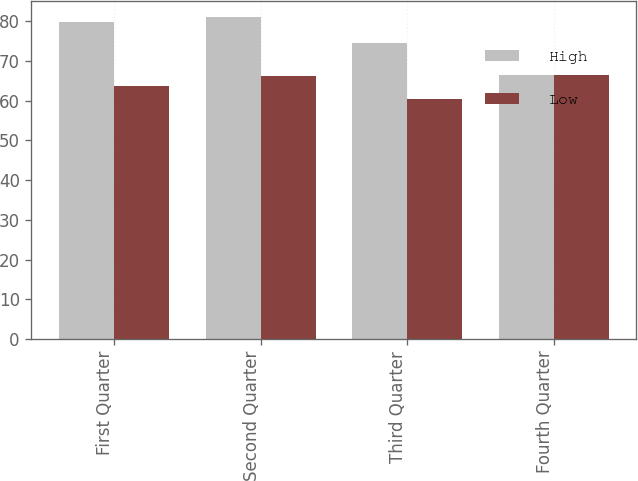Convert chart to OTSL. <chart><loc_0><loc_0><loc_500><loc_500><stacked_bar_chart><ecel><fcel>First Quarter<fcel>Second Quarter<fcel>Third Quarter<fcel>Fourth Quarter<nl><fcel>High<fcel>79.78<fcel>80.92<fcel>74.55<fcel>66.42<nl><fcel>Low<fcel>63.8<fcel>66.12<fcel>60.41<fcel>66.42<nl></chart> 